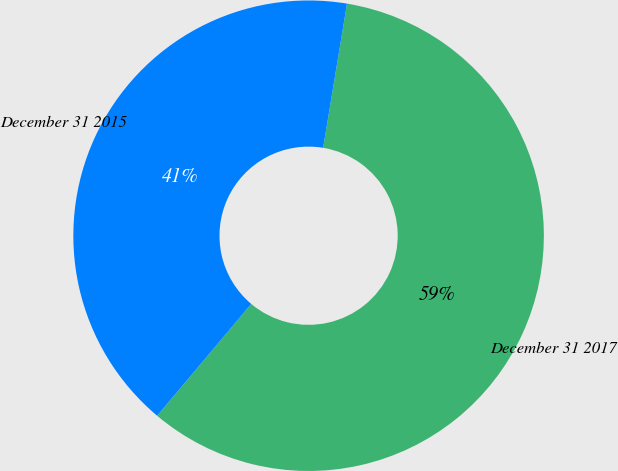Convert chart to OTSL. <chart><loc_0><loc_0><loc_500><loc_500><pie_chart><fcel>December 31 2017<fcel>December 31 2015<nl><fcel>58.52%<fcel>41.48%<nl></chart> 